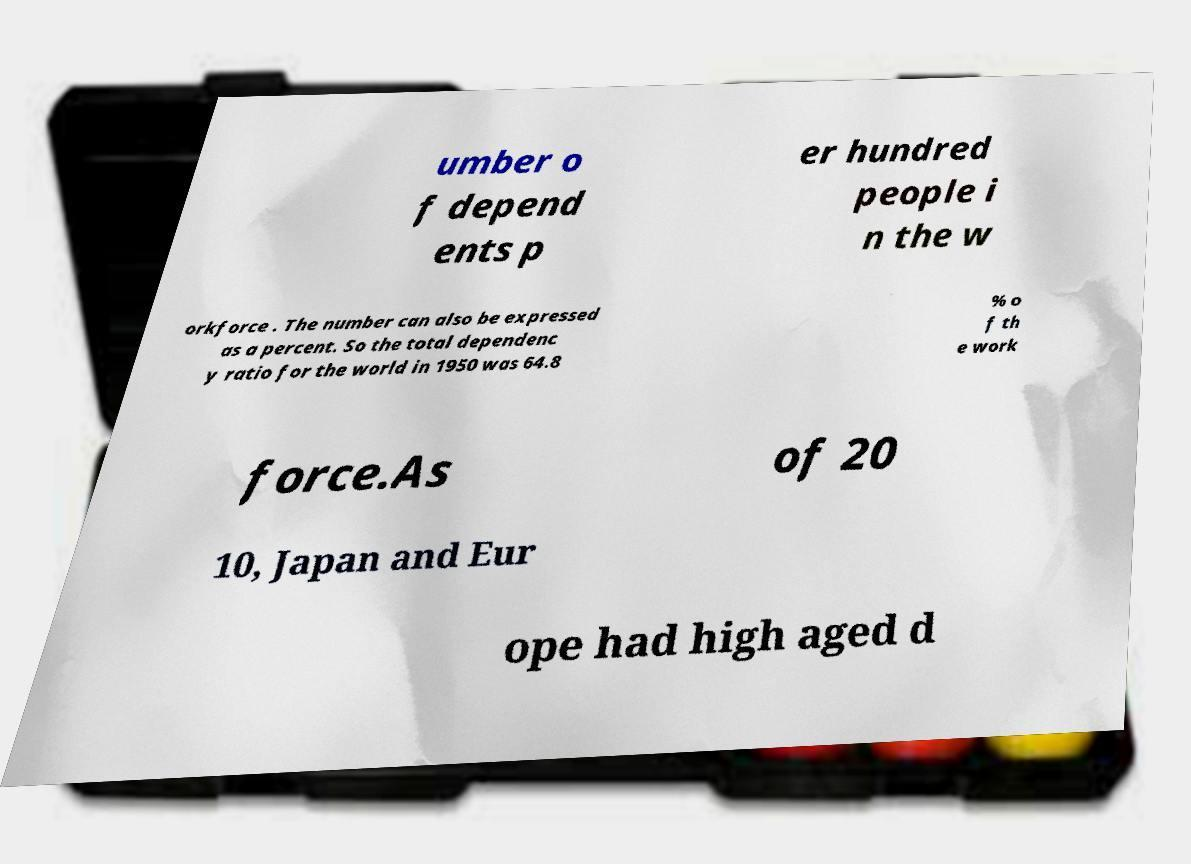Could you extract and type out the text from this image? umber o f depend ents p er hundred people i n the w orkforce . The number can also be expressed as a percent. So the total dependenc y ratio for the world in 1950 was 64.8 % o f th e work force.As of 20 10, Japan and Eur ope had high aged d 